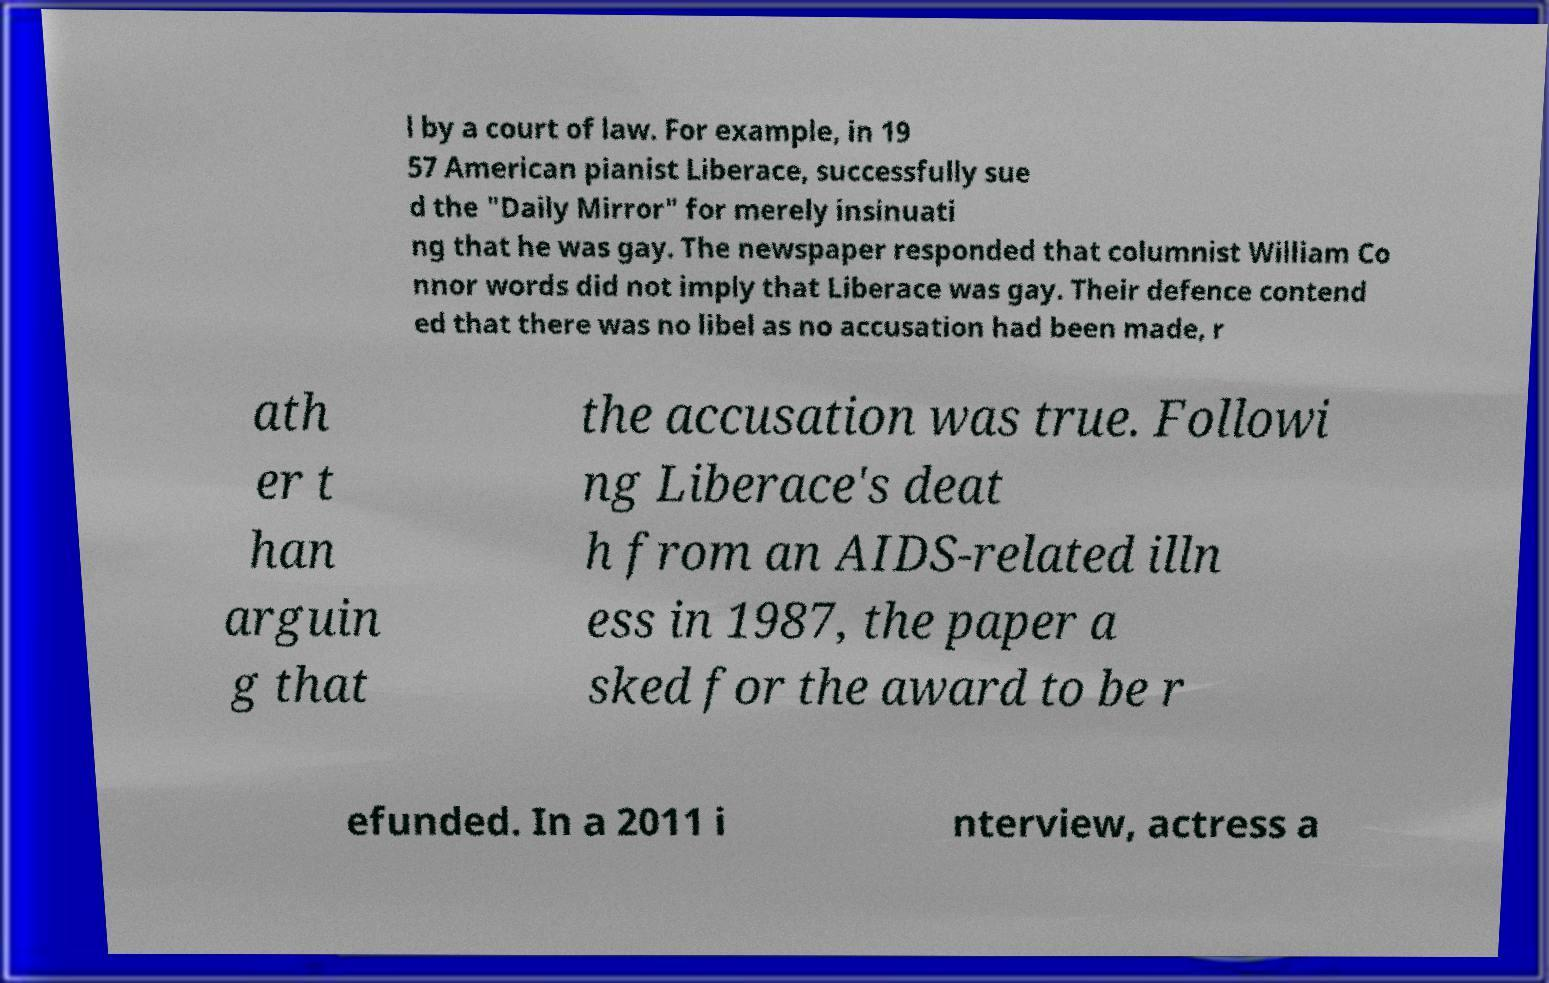Could you extract and type out the text from this image? l by a court of law. For example, in 19 57 American pianist Liberace, successfully sue d the "Daily Mirror" for merely insinuati ng that he was gay. The newspaper responded that columnist William Co nnor words did not imply that Liberace was gay. Their defence contend ed that there was no libel as no accusation had been made, r ath er t han arguin g that the accusation was true. Followi ng Liberace's deat h from an AIDS-related illn ess in 1987, the paper a sked for the award to be r efunded. In a 2011 i nterview, actress a 